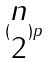Convert formula to latex. <formula><loc_0><loc_0><loc_500><loc_500>( \begin{matrix} n \\ 2 \end{matrix} ) p</formula> 